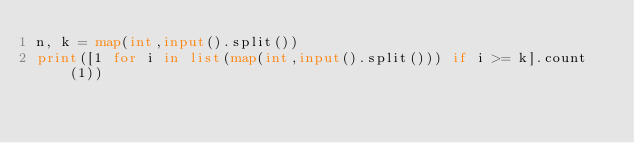Convert code to text. <code><loc_0><loc_0><loc_500><loc_500><_Python_>n, k = map(int,input().split())
print([1 for i in list(map(int,input().split())) if i >= k].count(1))</code> 